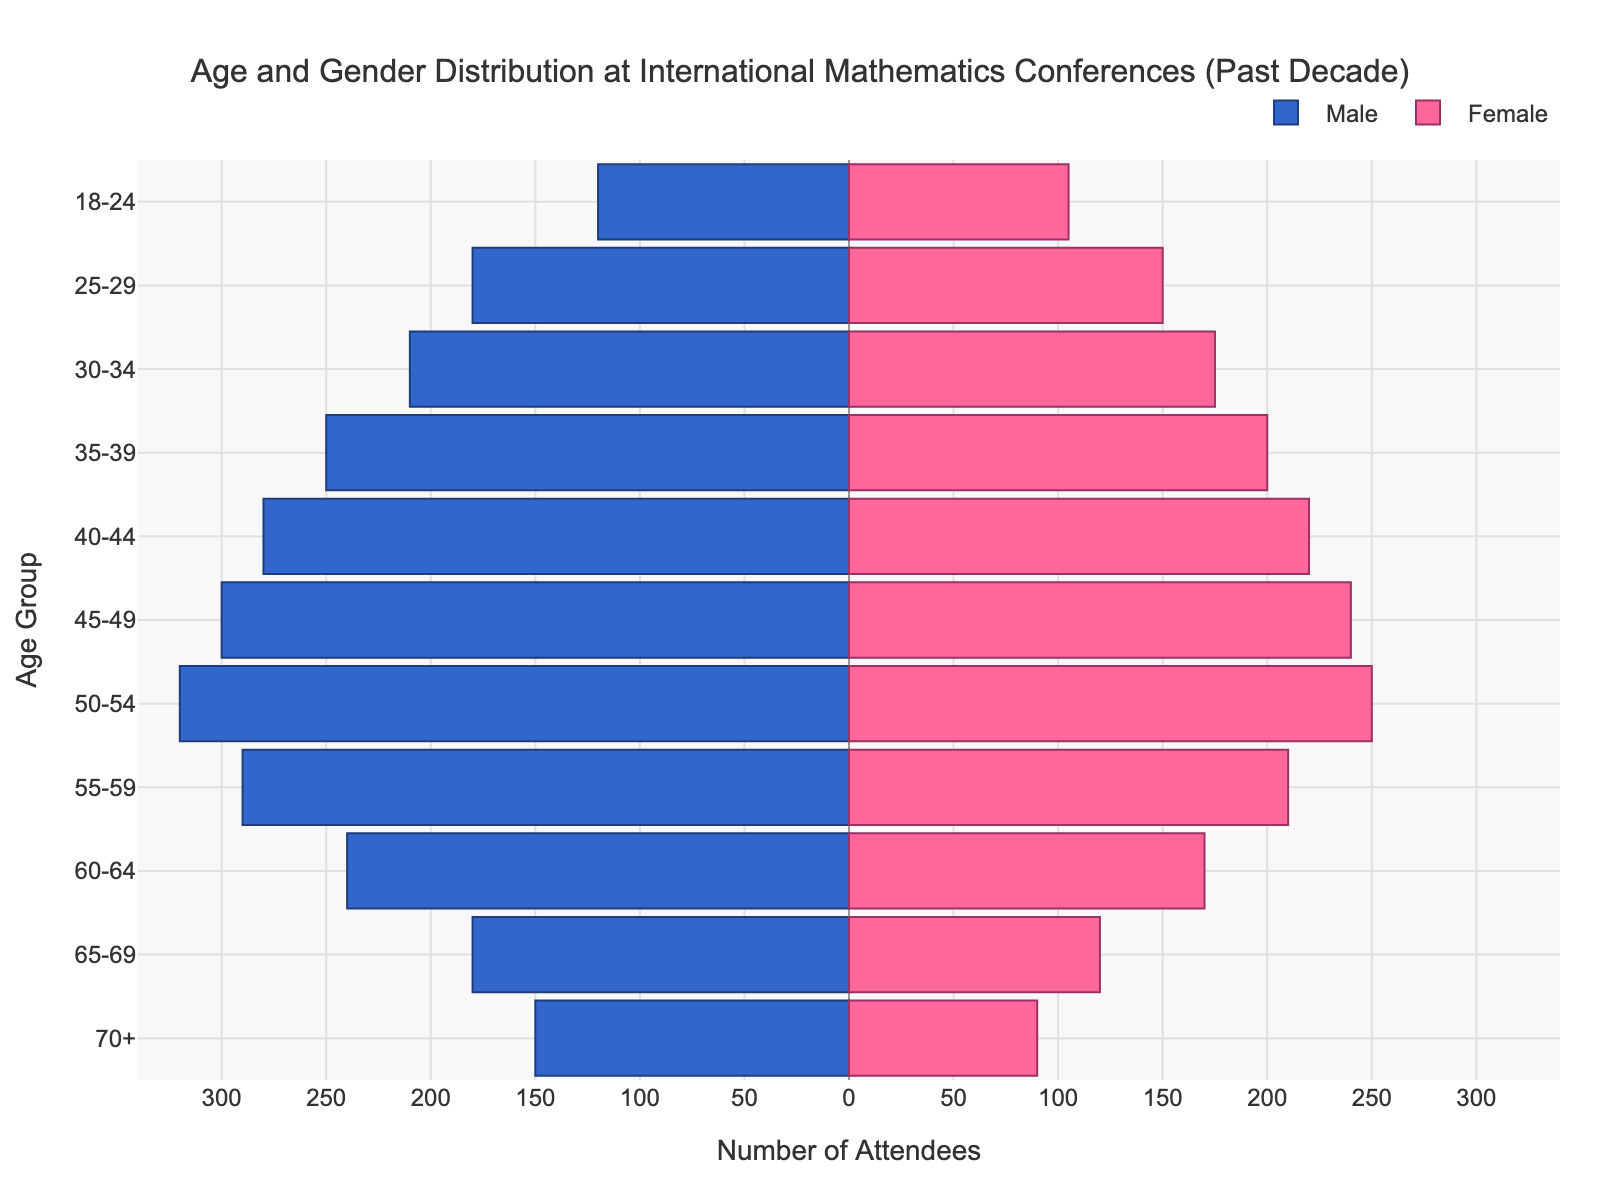What is the title of the figure? The title is usually placed at the top of the figure. Here, it reads "Age and Gender Distribution at International Mathematics Conferences (Past Decade)."
Answer: Age and Gender Distribution at International Mathematics Conferences (Past Decade) Which age group has the highest number of male attendees? By examining the bar lengths on the male side of the pyramid, the age group 50-54 has the longest bar, indicating the highest number of male attendees (320).
Answer: 50-54 In which age group is the male-to-female ratio closest to 1? To determine this, compare the male and female numbers for each age group. The age group 18-24 has 120 males and 105 females, giving a ratio of 120/105 which is approximately 1.14, the closest to 1 among all groups.
Answer: 18-24 How many more male attendees are there compared to female attendees in the 45-49 age group? The male count for 45-49 is 300, and the female count is 240. Subtracting the female count from the male gives 300 - 240 = 60.
Answer: 60 What is the total number of attendees in the 60-64 age group? Adding the male (240) and female (170) attendees in this group results in a total of 240 + 170 = 410 attendees.
Answer: 410 Which age group has the greatest difference between the number of male and female attendees? Calculate the difference for each age group, the group 50-54 has the largest difference (320 males - 250 females = 70).
Answer: 50-54 What is the trend in the number of attendees as the age increases from 18-24 to 70+ for males? Observe the lengths of the blue bars. The number of male attendees increases up to the 50-54 age group, then starts decreasing steadily as age increases further.
Answer: Increases then decreases Which age group has the fewest female attendees? The pink bar representing "70+" is the shortest among the female attendees, meaning this age group has the fewest female attendees (90).
Answer: 70+ What is the total number of attendees across all age groups? Sum all males (2750) and females (1930), resulting in a total of 2750 + 1930 = 4680 attendees.
Answer: 4680 In which two consecutive age groups is the increase in male attendees the highest? Looking at the lengths of the blue bars, the largest increase is between the age groups 35-39 (250) and 40-44 (280), with an increase of 280 - 250 = 30 attendees.
Answer: 35-39 and 40-44 